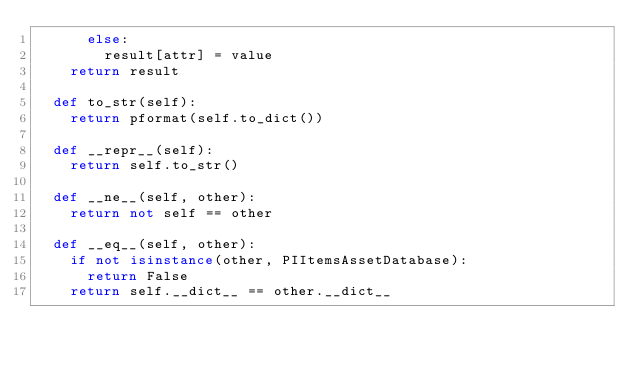<code> <loc_0><loc_0><loc_500><loc_500><_Python_>			else:
				result[attr] = value
		return result

	def to_str(self):
		return pformat(self.to_dict())

	def __repr__(self):
		return self.to_str()

	def __ne__(self, other):
		return not self == other

	def __eq__(self, other):
		if not isinstance(other, PIItemsAssetDatabase):
			return False
		return self.__dict__ == other.__dict__

</code> 